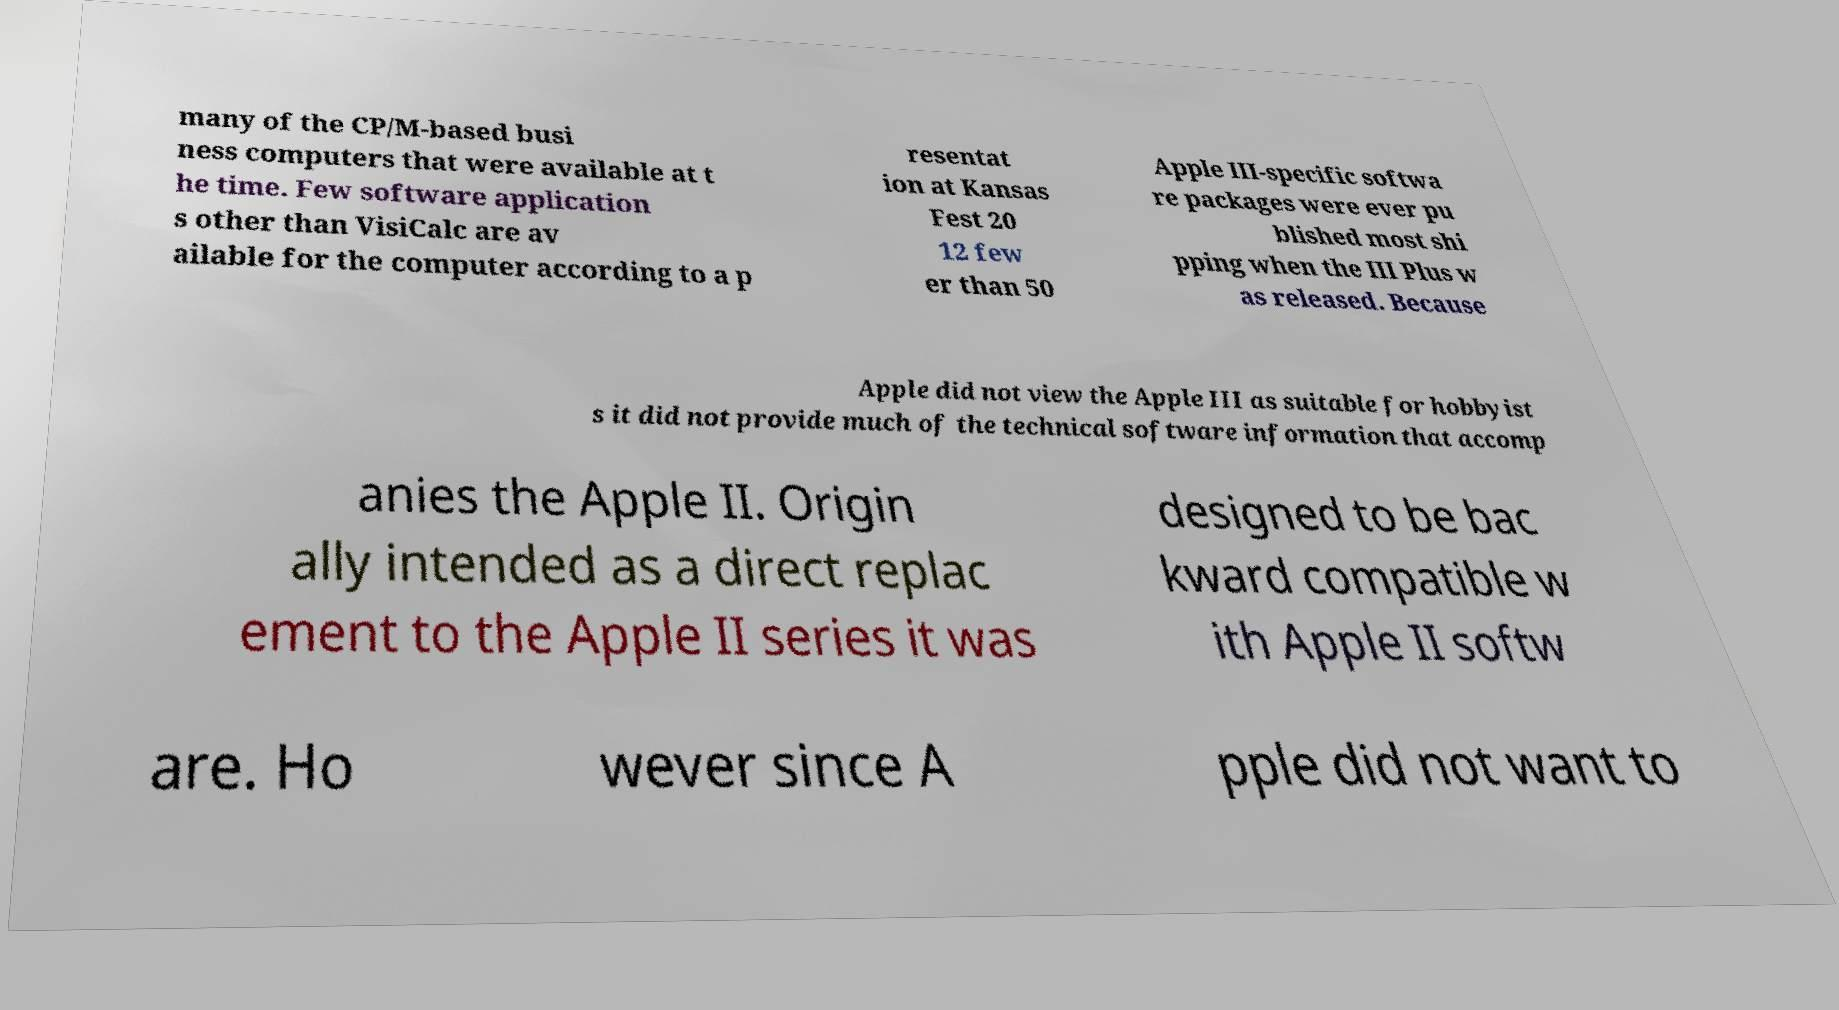Please identify and transcribe the text found in this image. many of the CP/M-based busi ness computers that were available at t he time. Few software application s other than VisiCalc are av ailable for the computer according to a p resentat ion at Kansas Fest 20 12 few er than 50 Apple III-specific softwa re packages were ever pu blished most shi pping when the III Plus w as released. Because Apple did not view the Apple III as suitable for hobbyist s it did not provide much of the technical software information that accomp anies the Apple II. Origin ally intended as a direct replac ement to the Apple II series it was designed to be bac kward compatible w ith Apple II softw are. Ho wever since A pple did not want to 